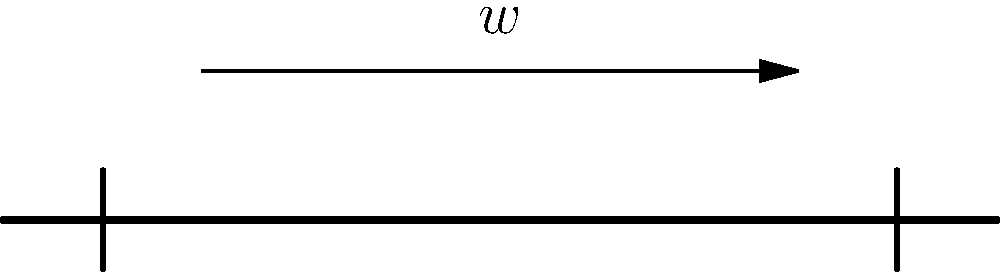A simply supported beam of length $L$ is subjected to a uniformly distributed load $w$ across its entire span. Determine the maximum bending moment $M_{max}$ in the beam in terms of $w$ and $L$. How does this compare to the maximum bending moment in a cantilever beam of the same length and loading? To solve this problem, let's follow these steps:

1) For a simply supported beam with uniformly distributed load:
   - The reaction forces at the supports are equal: $R_A = R_B = \frac{wL}{2}$

2) The bending moment equation for any point $x$ along the beam is:
   $M(x) = R_A \cdot x - w \cdot x \cdot \frac{x}{2}$

3) The maximum bending moment occurs at the middle of the beam $(x = \frac{L}{2})$:
   $M_{max} = \frac{wL}{2} \cdot \frac{L}{2} - w \cdot \frac{L}{2} \cdot \frac{L}{4}$

4) Simplifying:
   $M_{max} = \frac{wL^2}{8}$

5) For a cantilever beam of the same length and loading:
   $M_{max(cantilever)} = \frac{wL^2}{2}$

6) Comparing the two:
   $\frac{M_{max(simply supported)}}{M_{max(cantilever)}} = \frac{\frac{wL^2}{8}}{\frac{wL^2}{2}} = \frac{1}{4}$

Therefore, the maximum bending moment in the simply supported beam is one-fourth of that in the cantilever beam.

This comparison illustrates how different support conditions can significantly affect stress distribution in beams, which is crucial in understanding antibiotic resistance gene evolution in different environmental conditions.
Answer: $M_{max} = \frac{wL^2}{8}$; 1/4 of cantilever beam's maximum moment 